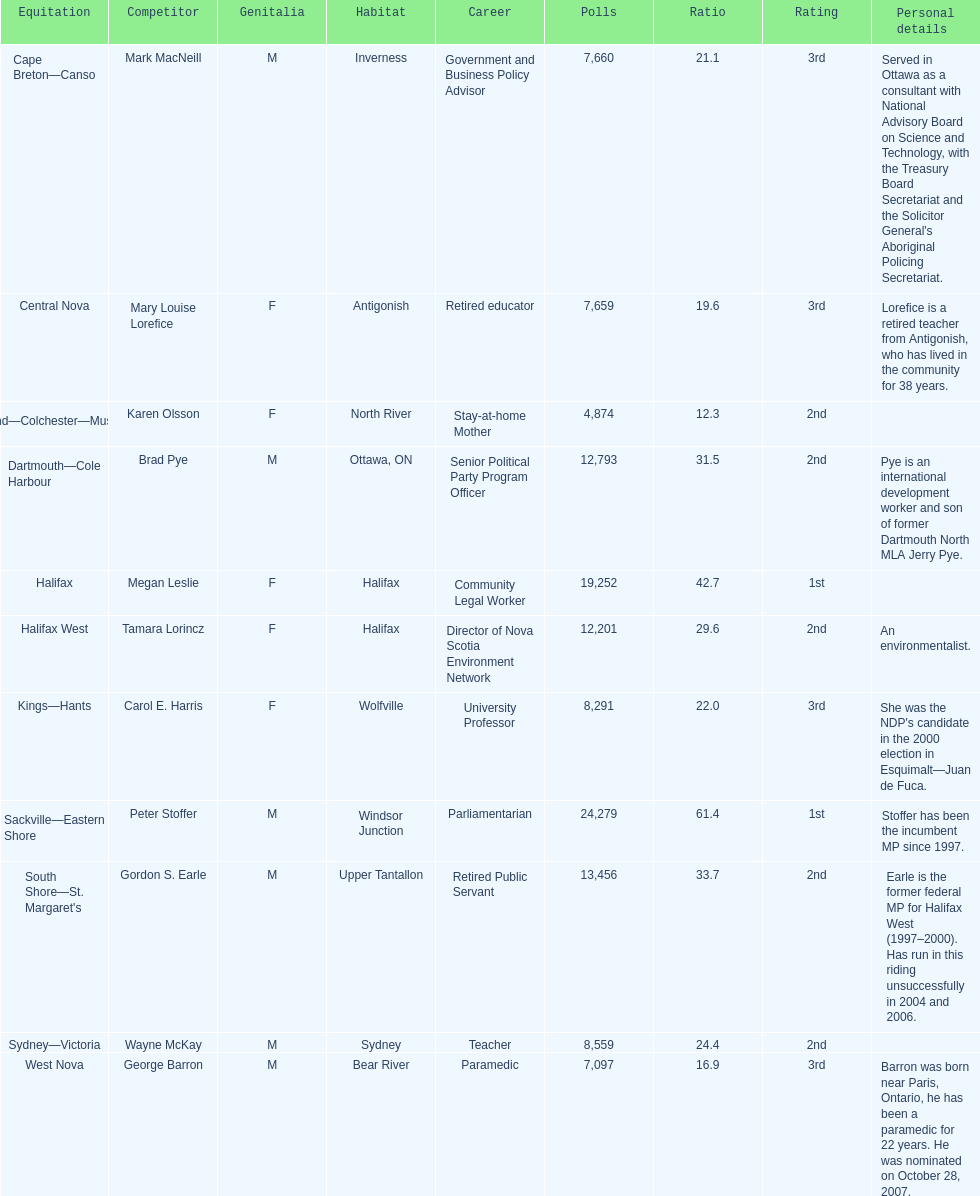What is the total number of candidates? 11. 